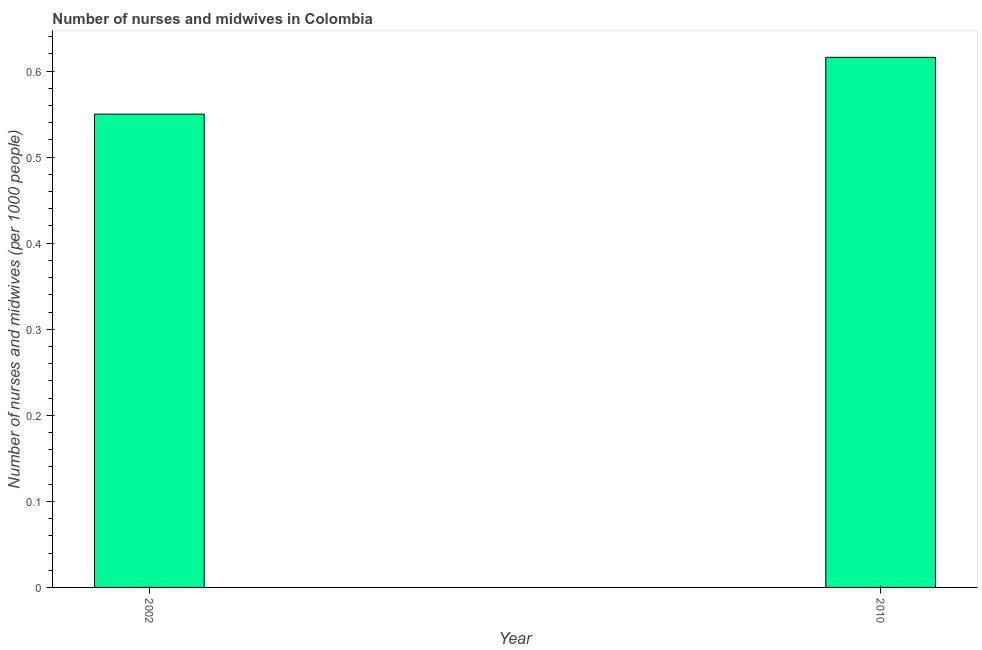What is the title of the graph?
Ensure brevity in your answer.  Number of nurses and midwives in Colombia. What is the label or title of the X-axis?
Your answer should be very brief. Year. What is the label or title of the Y-axis?
Make the answer very short. Number of nurses and midwives (per 1000 people). What is the number of nurses and midwives in 2010?
Ensure brevity in your answer.  0.62. Across all years, what is the maximum number of nurses and midwives?
Your answer should be very brief. 0.62. Across all years, what is the minimum number of nurses and midwives?
Make the answer very short. 0.55. In which year was the number of nurses and midwives minimum?
Provide a succinct answer. 2002. What is the sum of the number of nurses and midwives?
Offer a terse response. 1.17. What is the difference between the number of nurses and midwives in 2002 and 2010?
Your answer should be compact. -0.07. What is the average number of nurses and midwives per year?
Make the answer very short. 0.58. What is the median number of nurses and midwives?
Offer a terse response. 0.58. What is the ratio of the number of nurses and midwives in 2002 to that in 2010?
Your answer should be compact. 0.89. In how many years, is the number of nurses and midwives greater than the average number of nurses and midwives taken over all years?
Ensure brevity in your answer.  1. How many years are there in the graph?
Make the answer very short. 2. Are the values on the major ticks of Y-axis written in scientific E-notation?
Ensure brevity in your answer.  No. What is the Number of nurses and midwives (per 1000 people) of 2002?
Your response must be concise. 0.55. What is the Number of nurses and midwives (per 1000 people) in 2010?
Ensure brevity in your answer.  0.62. What is the difference between the Number of nurses and midwives (per 1000 people) in 2002 and 2010?
Your answer should be compact. -0.07. What is the ratio of the Number of nurses and midwives (per 1000 people) in 2002 to that in 2010?
Your answer should be very brief. 0.89. 